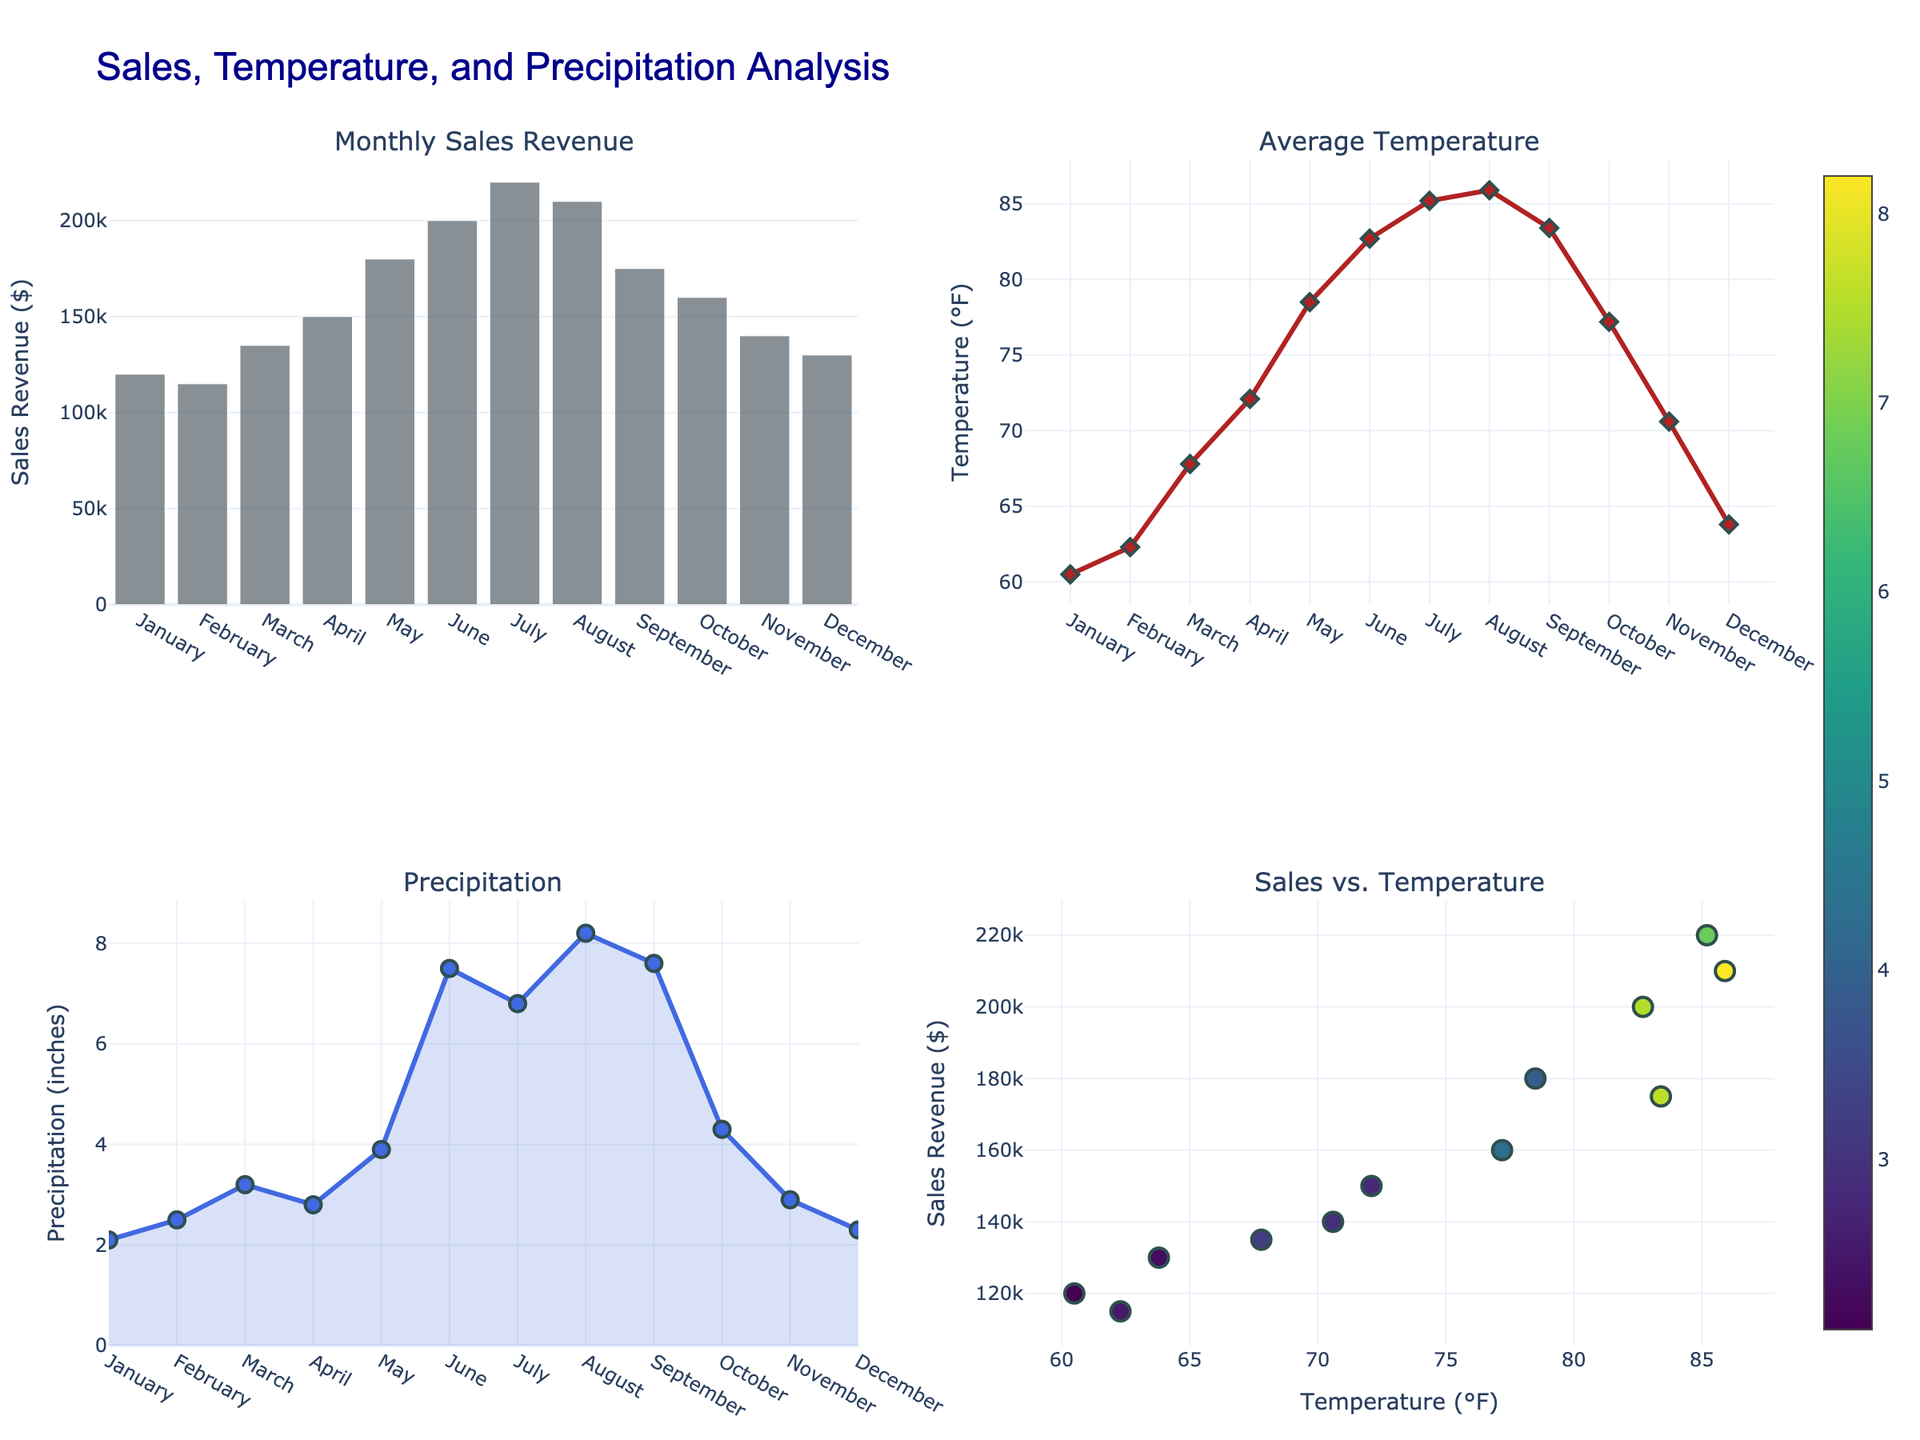What is the total number of applications for Artificial Intelligence in 2020? The figure shows the number of patent applications for Artificial Intelligence in each year within the line plot "AI vs Blockchain". For the year 2020, the data point for Artificial Intelligence shows 22,000 applications.
Answer: 22,000 What is the percentage of Blockchain patents in 2022 compared to other technologies? In the pie chart titled "2022 Market Share", each technology's percentage is displayed directly on the chart. The percentage for Blockchain in 2022 is 17.5%.
Answer: 17.5% Which technology showed the highest growth rate from 2018 to 2022? The bar chart in the fourth subplot, which shows the growth rates of different technologies from 2018 to 2022, displays the highest bar for Artificial Intelligence. Hence, AI has the highest growth rate.
Answer: Artificial Intelligence Between AI and Blockchain, which technology had a larger increase in patent applications from 2019 to 2020? The line plot for "AI vs Blockchain" shows the trend for both technologies. For AI, the increase is from 18,500 to 22,000 (an increase of 3,500). For Blockchain, the increase is from 10,000 to 12,500 (an increase of 2,500). AI had a larger increase.
Answer: Artificial Intelligence How many more patent applications were there for Nanotechnology compared to Quantum Computing in 2021? The line plot for "Technology Trends" shows the number of applications for each technology in each year. For 2021, Nanotechnology had 18,000 applications, and Quantum Computing had 4,200 applications. The difference is 18,000 - 4,200, which equals 13,800.
Answer: 13,800 Which technology had the lowest number of patent applications in 2018? The line plot for "Technology Trends" shows the number of applications for each technology in 2018. Quantum Computing had the lowest number with 2,000 applications.
Answer: Quantum Computing How has the number of patent applications for Gene Editing changed from 2020 to 2022? From the line plot for "Technology Trends", Gene Editing had 8,000 applications in 2020 and increased to 11,000 applications in 2022. The number of applications has increased by 3,000 from 2020 to 2022.
Answer: Increased by 3,000 Which technology has the highest market share in 2022 according to the pie chart? The pie chart "2022 Market Share" displays the portions each technology holds. Artificial Intelligence has the largest section, thus the highest market share.
Answer: Artificial Intelligence 